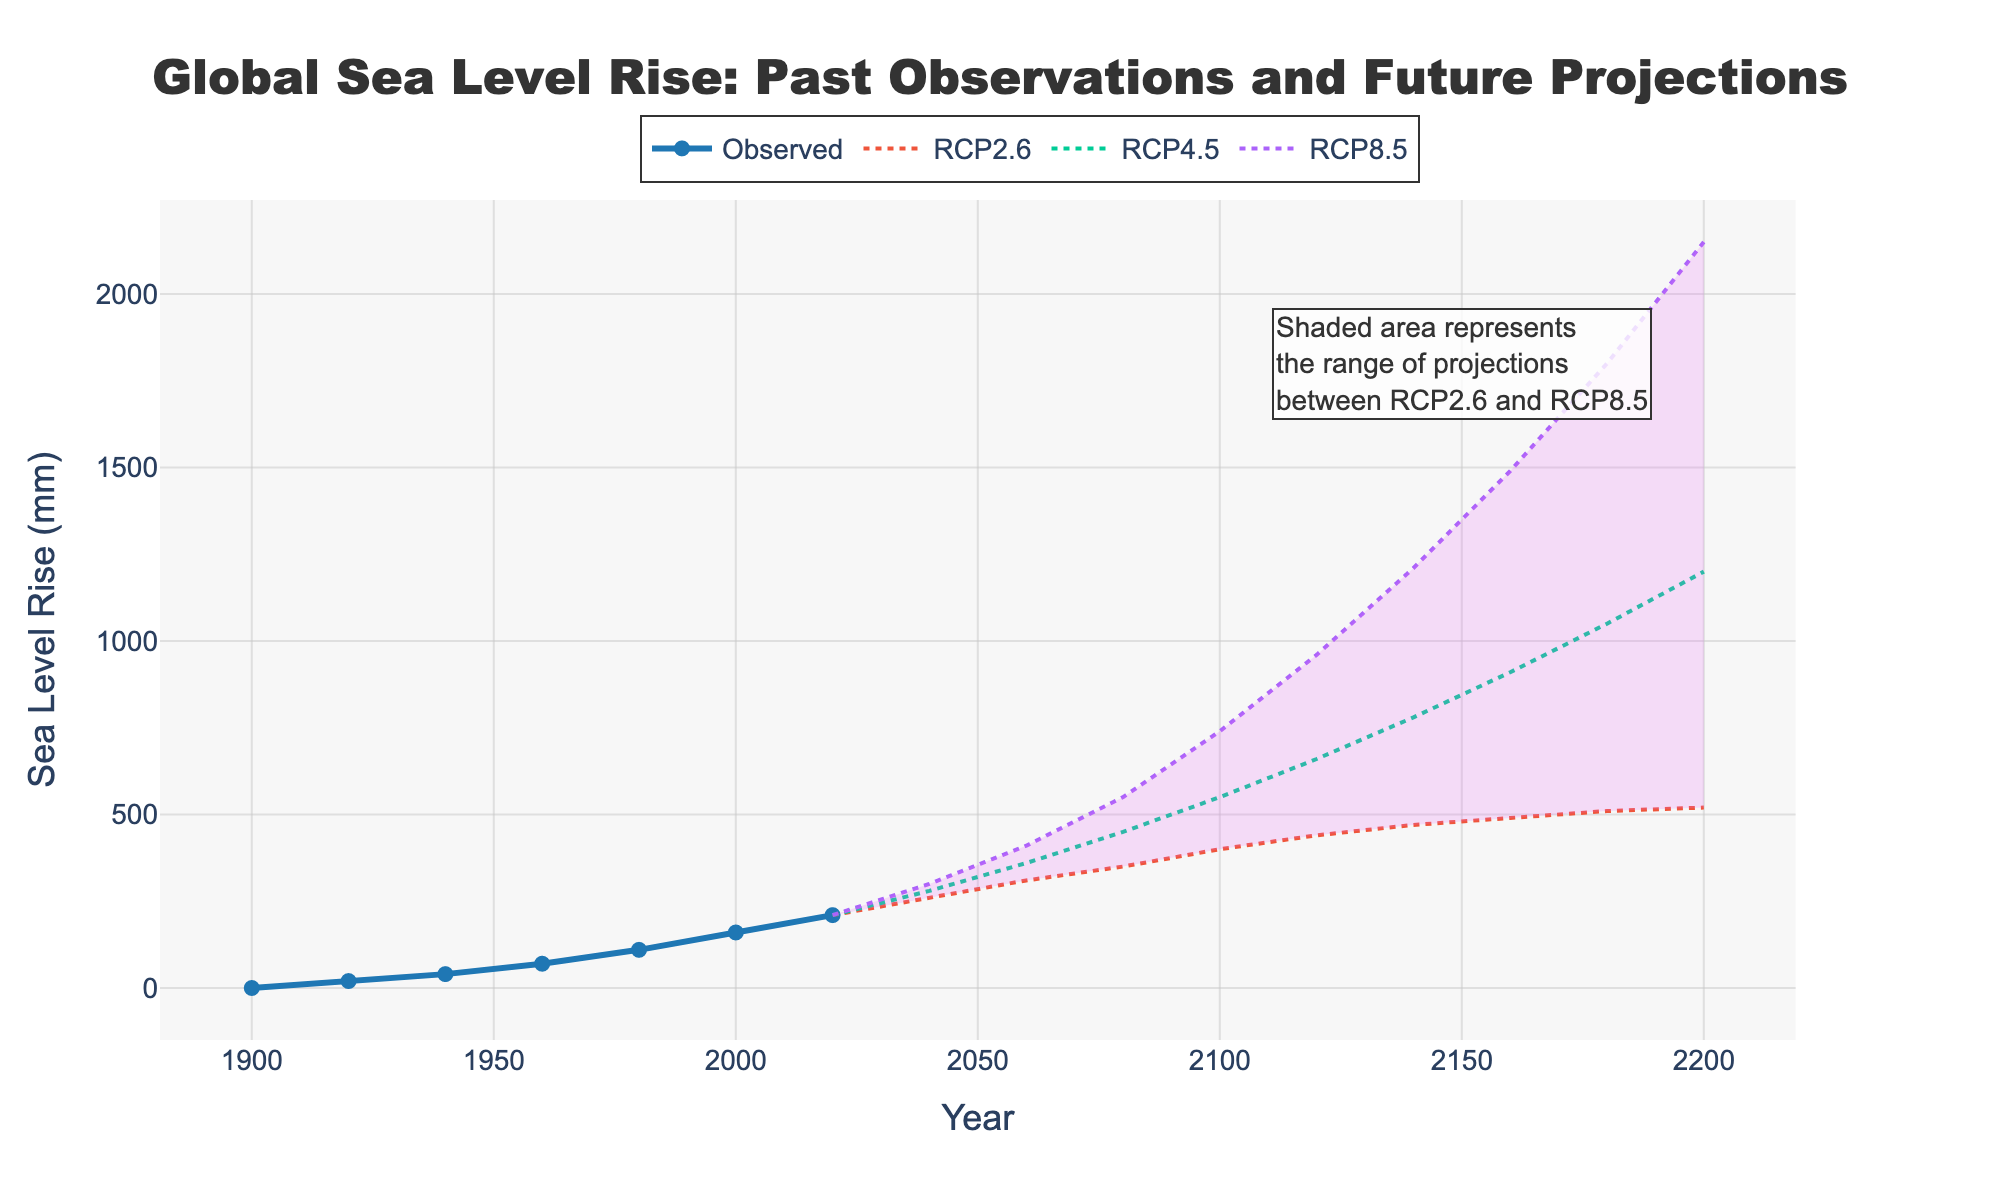What's the observed increase in sea level between 1900 and 2000? Look at the values for observed sea level rise for the years 1900 and 2000. The value in 1900 is 0 mm, and in 2000 it's 160 mm. The increase is 160 mm - 0 mm = 160 mm.
Answer: 160 mm Which scenario projects the highest sea level rise in 2160? Compare the projected sea level rise values for the year 2160 across the RCP scenarios. The values are 490 mm (RCP2.6), 910 mm (RCP4.5), and 1490 mm (RCP8.5). The highest value is 1490 mm from the RCP8.5 scenario.
Answer: RCP8.5 What is the difference between the RCP2.6 and RCP8.5 projections for the year 2200? Look at the sea level rise projections for RCP2.6 and RCP8.5 in the year 2200. The values are 520 mm for RCP2.6 and 2150 mm for RCP8.5. The difference is 2150 mm - 520 mm = 1630 mm.
Answer: 1630 mm How much did the observed sea level rise between 1980 and 2020? Check the observed sea level rise values for the years 1980 and 2020. The values are 110 mm in 1980 and 210 mm in 2020. The rise is 210 mm - 110 mm = 100 mm.
Answer: 100 mm What is the range of projections for the year 2080? For 2080, check the lowest and highest projected values. RCP2.6 is 350 mm, RCP4.5 is 450 mm, and RCP8.5 is 550 mm. The range is from 350 mm to 550 mm.
Answer: 350 mm to 550 mm Between which years does the shaded area start appearing on the plot? The shaded area represents the projection range and starts from the year when projections begin. Projections start from 2020, so the shaded area begins then.
Answer: 2020 Which projection scenario shows the steepest increase in sea level rise from 2040 to 2100? Calculate the increase for each scenario between 2040 and 2100: RCP2.6: 400 mm - 260 mm = 140 mm; RCP4.5: 550 mm - 280 mm = 270 mm; RCP8.5: 740 mm - 300 mm = 440 mm. The steepest increase is in RCP8.5 (440 mm).
Answer: RCP8.5 What is the projected sea level rise in 2120 according to RCP4.5? Locate the projected value for RCP4.5 in the year 2120 on the chart. The value is 660 mm.
Answer: 660 mm 